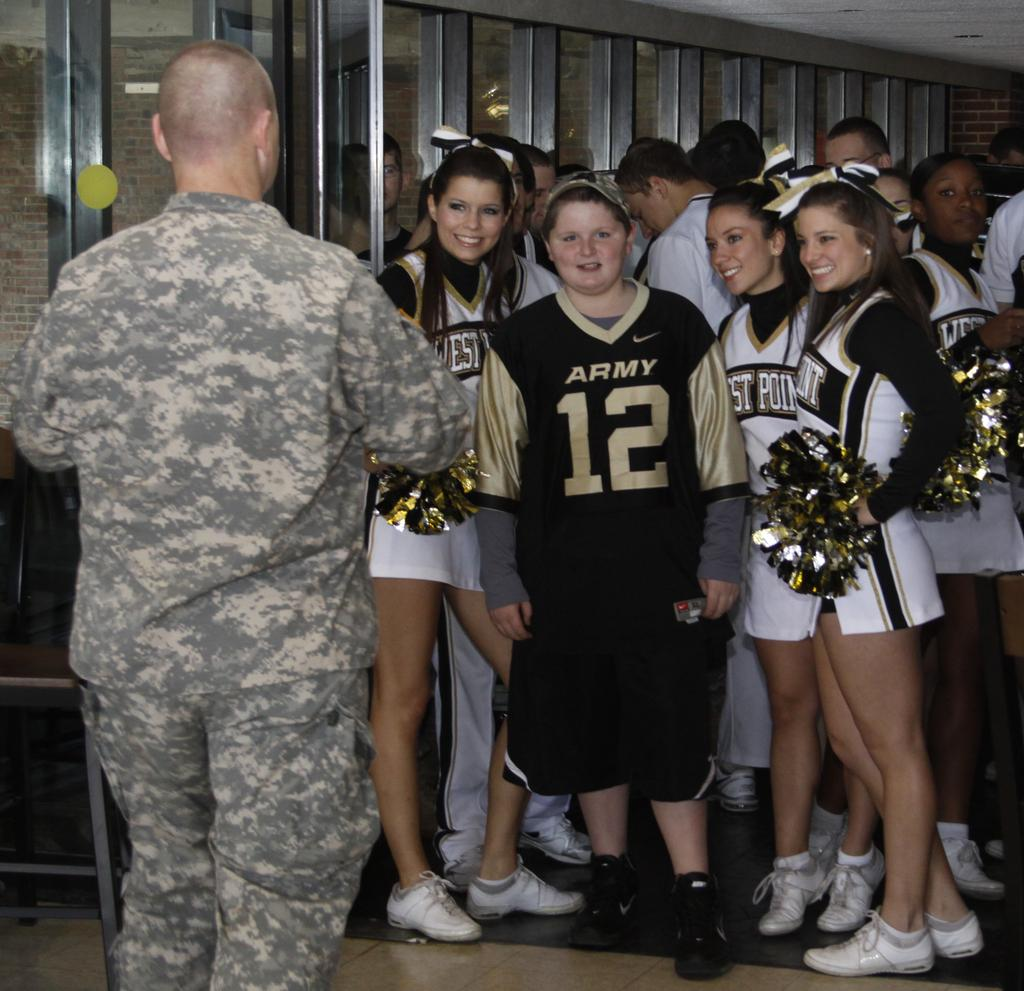<image>
Relay a brief, clear account of the picture shown. A boy wearing an Army jersey stands among West Point cheerleaders 